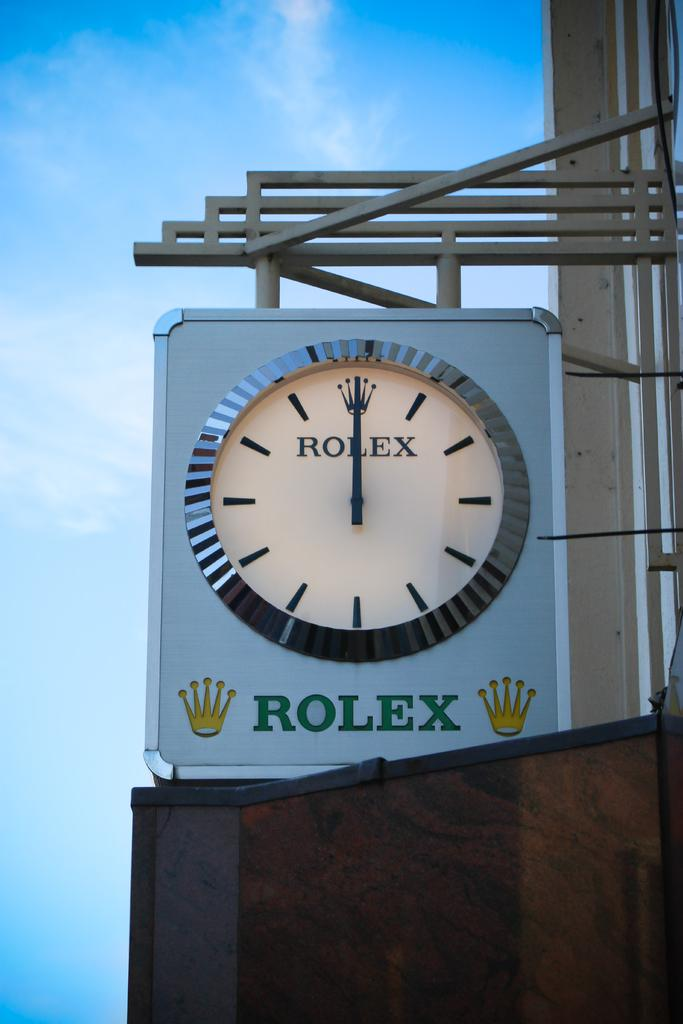<image>
Give a short and clear explanation of the subsequent image. An outdoor Rolex clock shows that the time is now 12:00. 